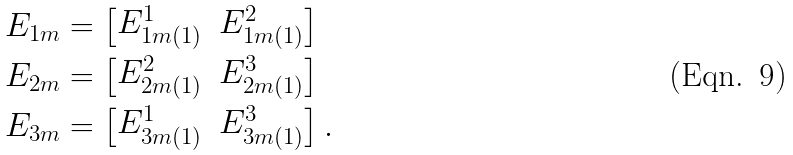Convert formula to latex. <formula><loc_0><loc_0><loc_500><loc_500>& E _ { 1 m } = \left [ \begin{matrix} E _ { 1 m ( 1 ) } ^ { 1 } & E _ { 1 m ( 1 ) } ^ { 2 } \end{matrix} \right ] \\ & E _ { 2 m } = \left [ \begin{matrix} E _ { 2 m ( 1 ) } ^ { 2 } & E _ { 2 m ( 1 ) } ^ { 3 } \end{matrix} \right ] \\ & E _ { 3 m } = \left [ \begin{matrix} E _ { 3 m ( 1 ) } ^ { 1 } & E _ { 3 m ( 1 ) } ^ { 3 } \end{matrix} \right ] .</formula> 